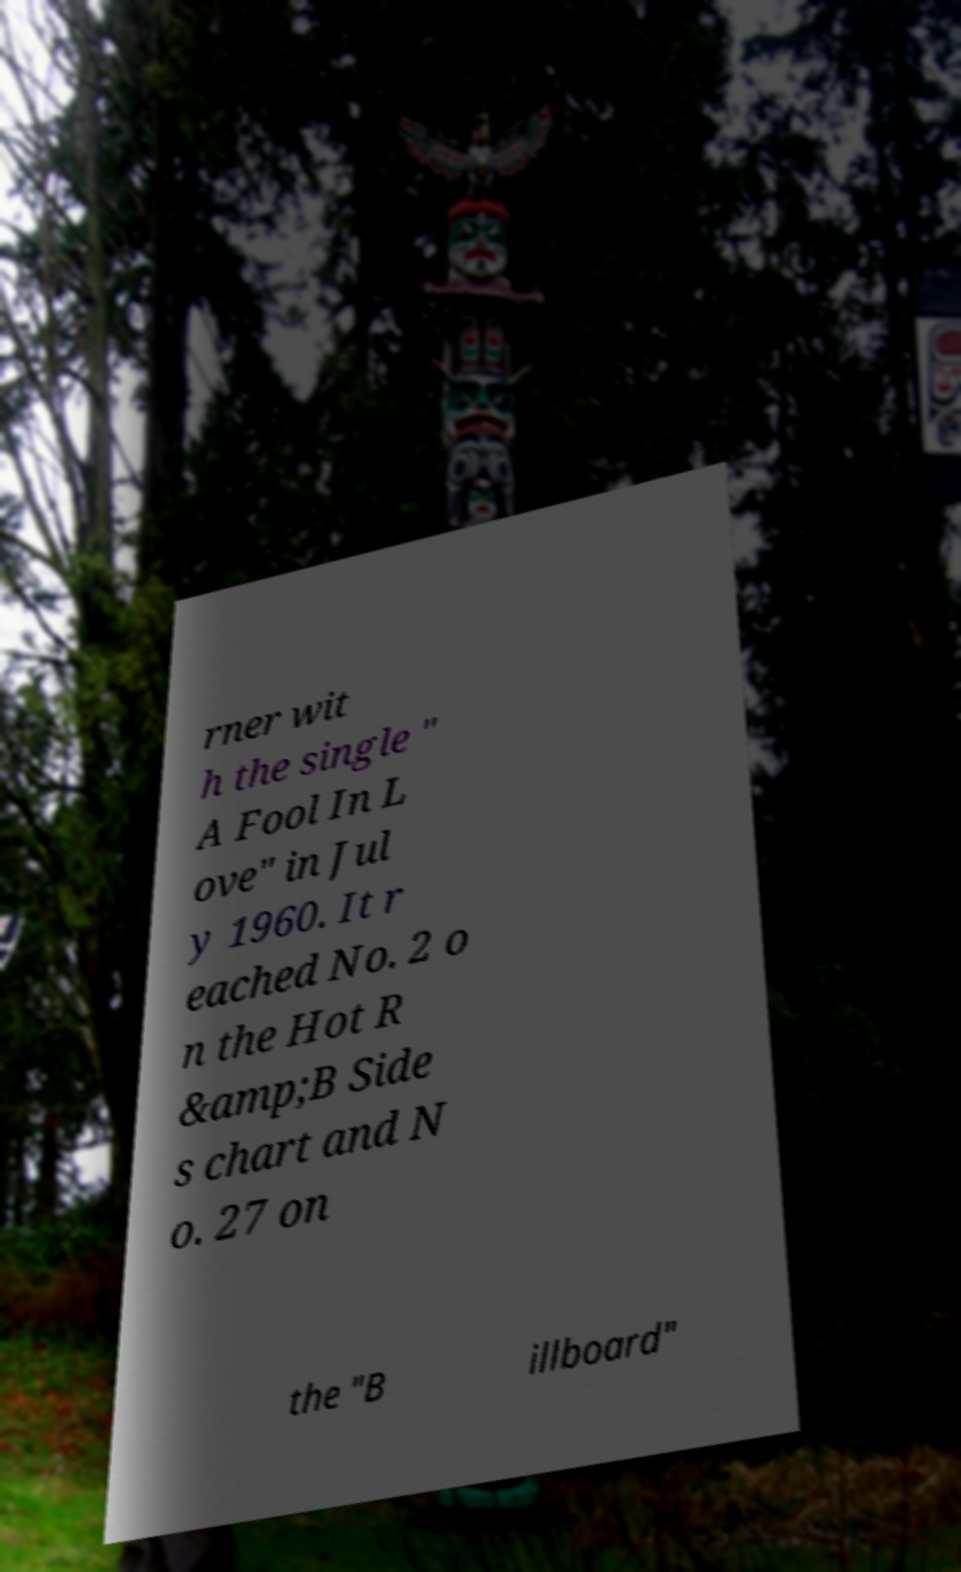Could you extract and type out the text from this image? rner wit h the single " A Fool In L ove" in Jul y 1960. It r eached No. 2 o n the Hot R &amp;B Side s chart and N o. 27 on the "B illboard" 